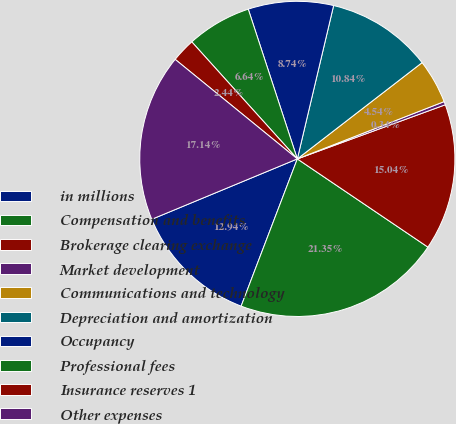<chart> <loc_0><loc_0><loc_500><loc_500><pie_chart><fcel>in millions<fcel>Compensation and benefits<fcel>Brokerage clearing exchange<fcel>Market development<fcel>Communications and technology<fcel>Depreciation and amortization<fcel>Occupancy<fcel>Professional fees<fcel>Insurance reserves 1<fcel>Other expenses<nl><fcel>12.94%<fcel>21.35%<fcel>15.04%<fcel>0.34%<fcel>4.54%<fcel>10.84%<fcel>8.74%<fcel>6.64%<fcel>2.44%<fcel>17.14%<nl></chart> 